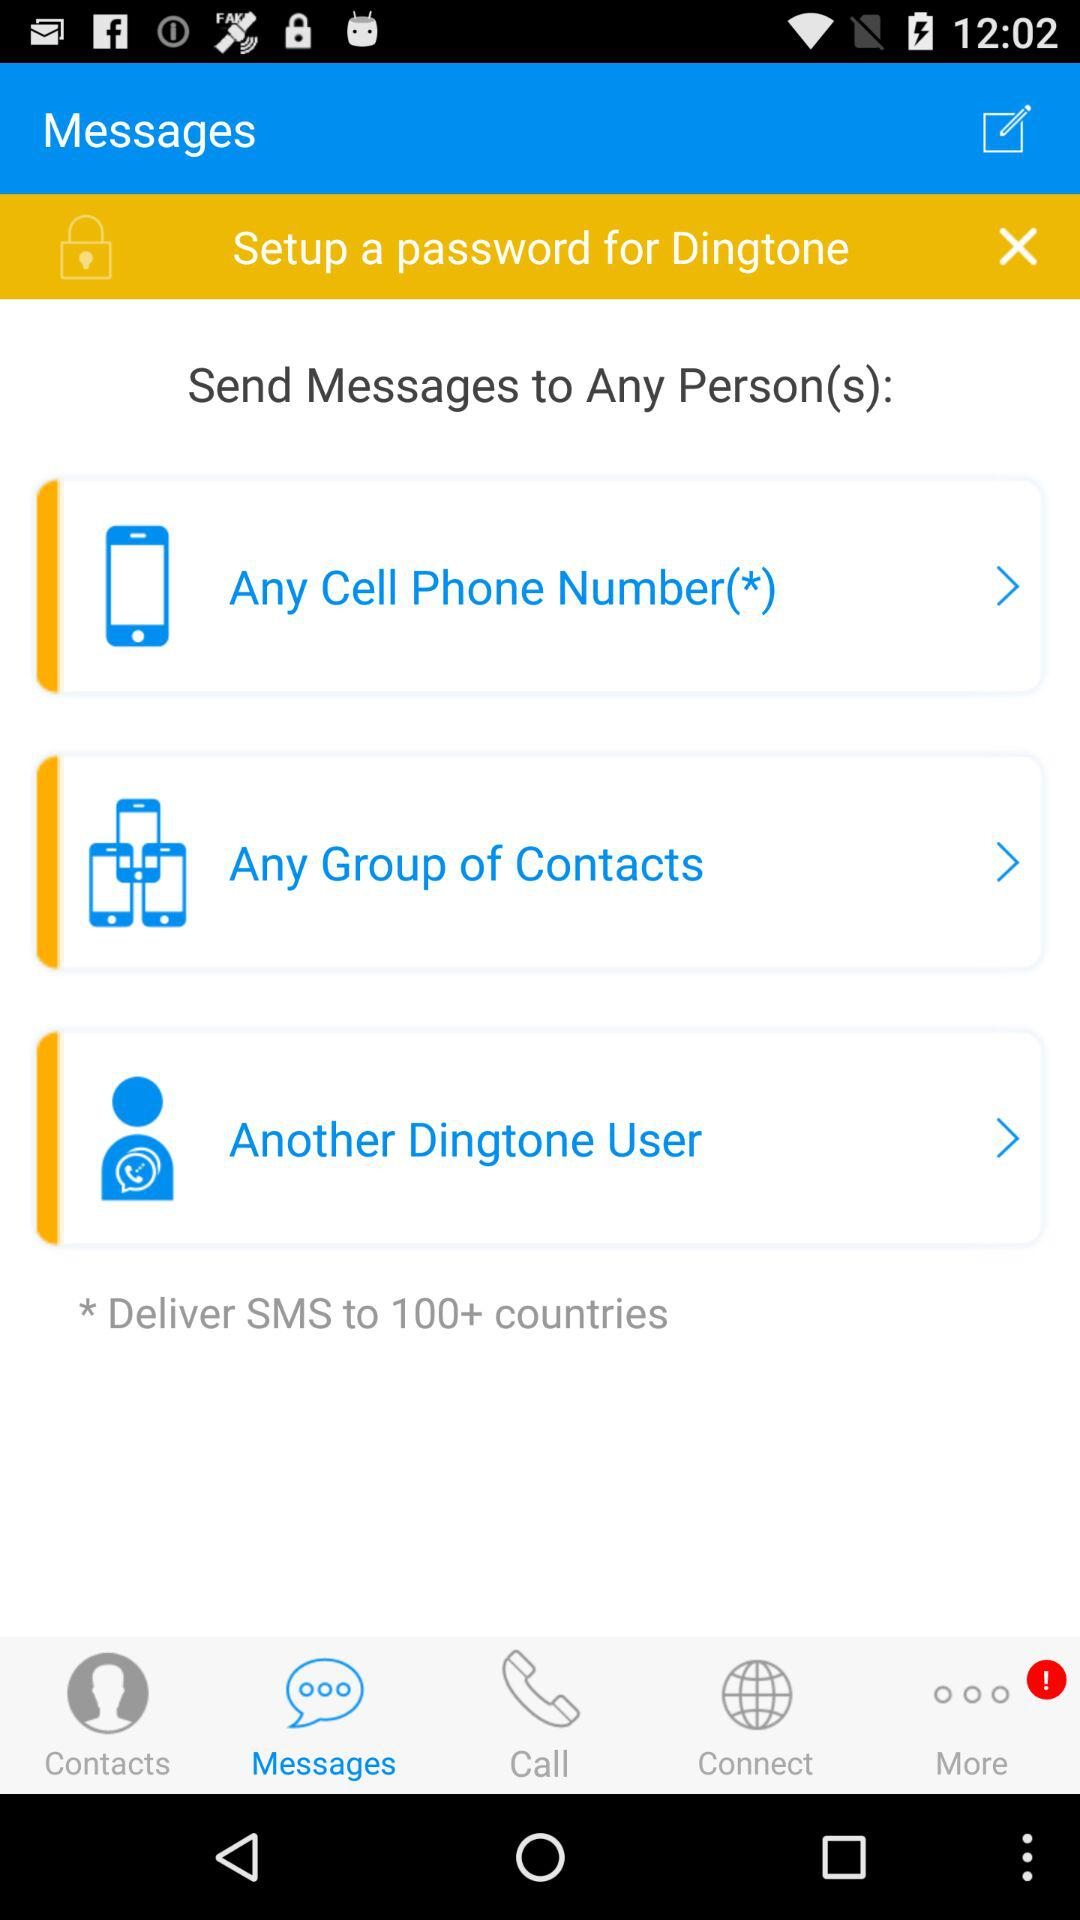What tab has an alert sign? The tab that has an alert sign is "More". 